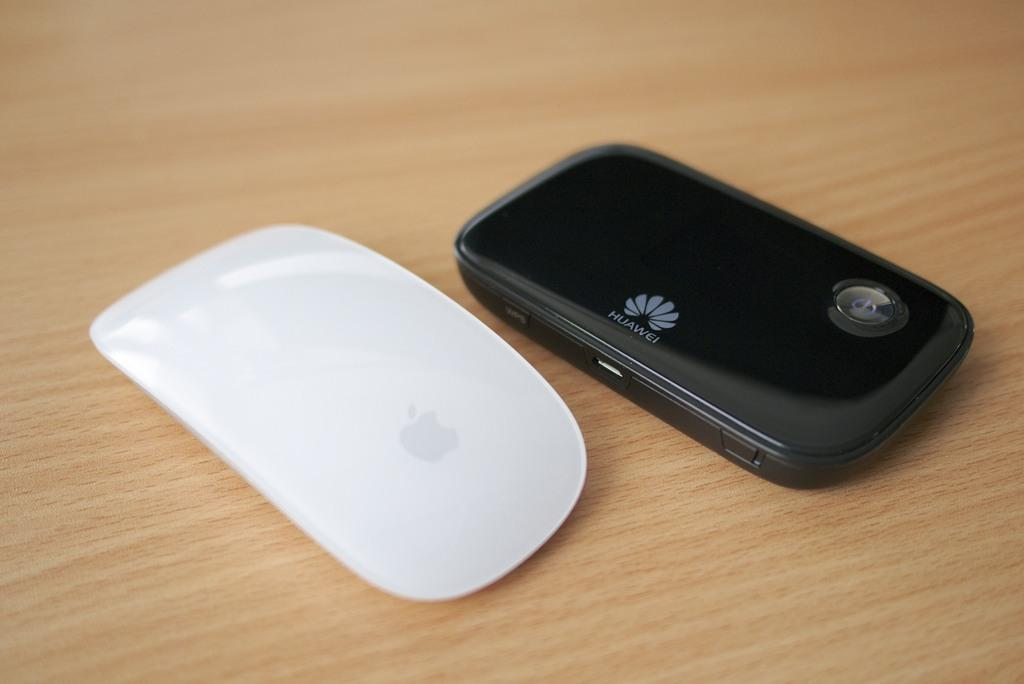<image>
Write a terse but informative summary of the picture. A white apple mouse is sitting next to a Huawei mobile device. 